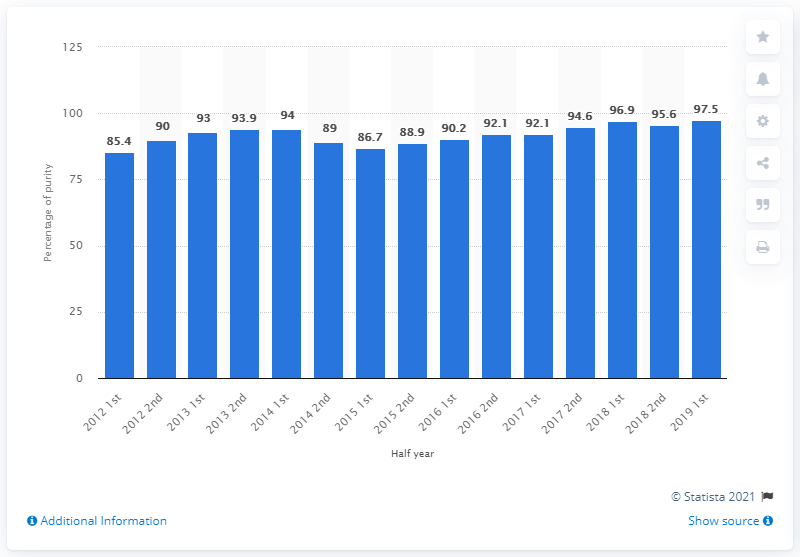Mention a couple of crucial points in this snapshot. In the first half of 2019, the potency of methamphetamine was 97.5%. During early 2012, the potency level of methamphetamine was found to be 85.4%. 